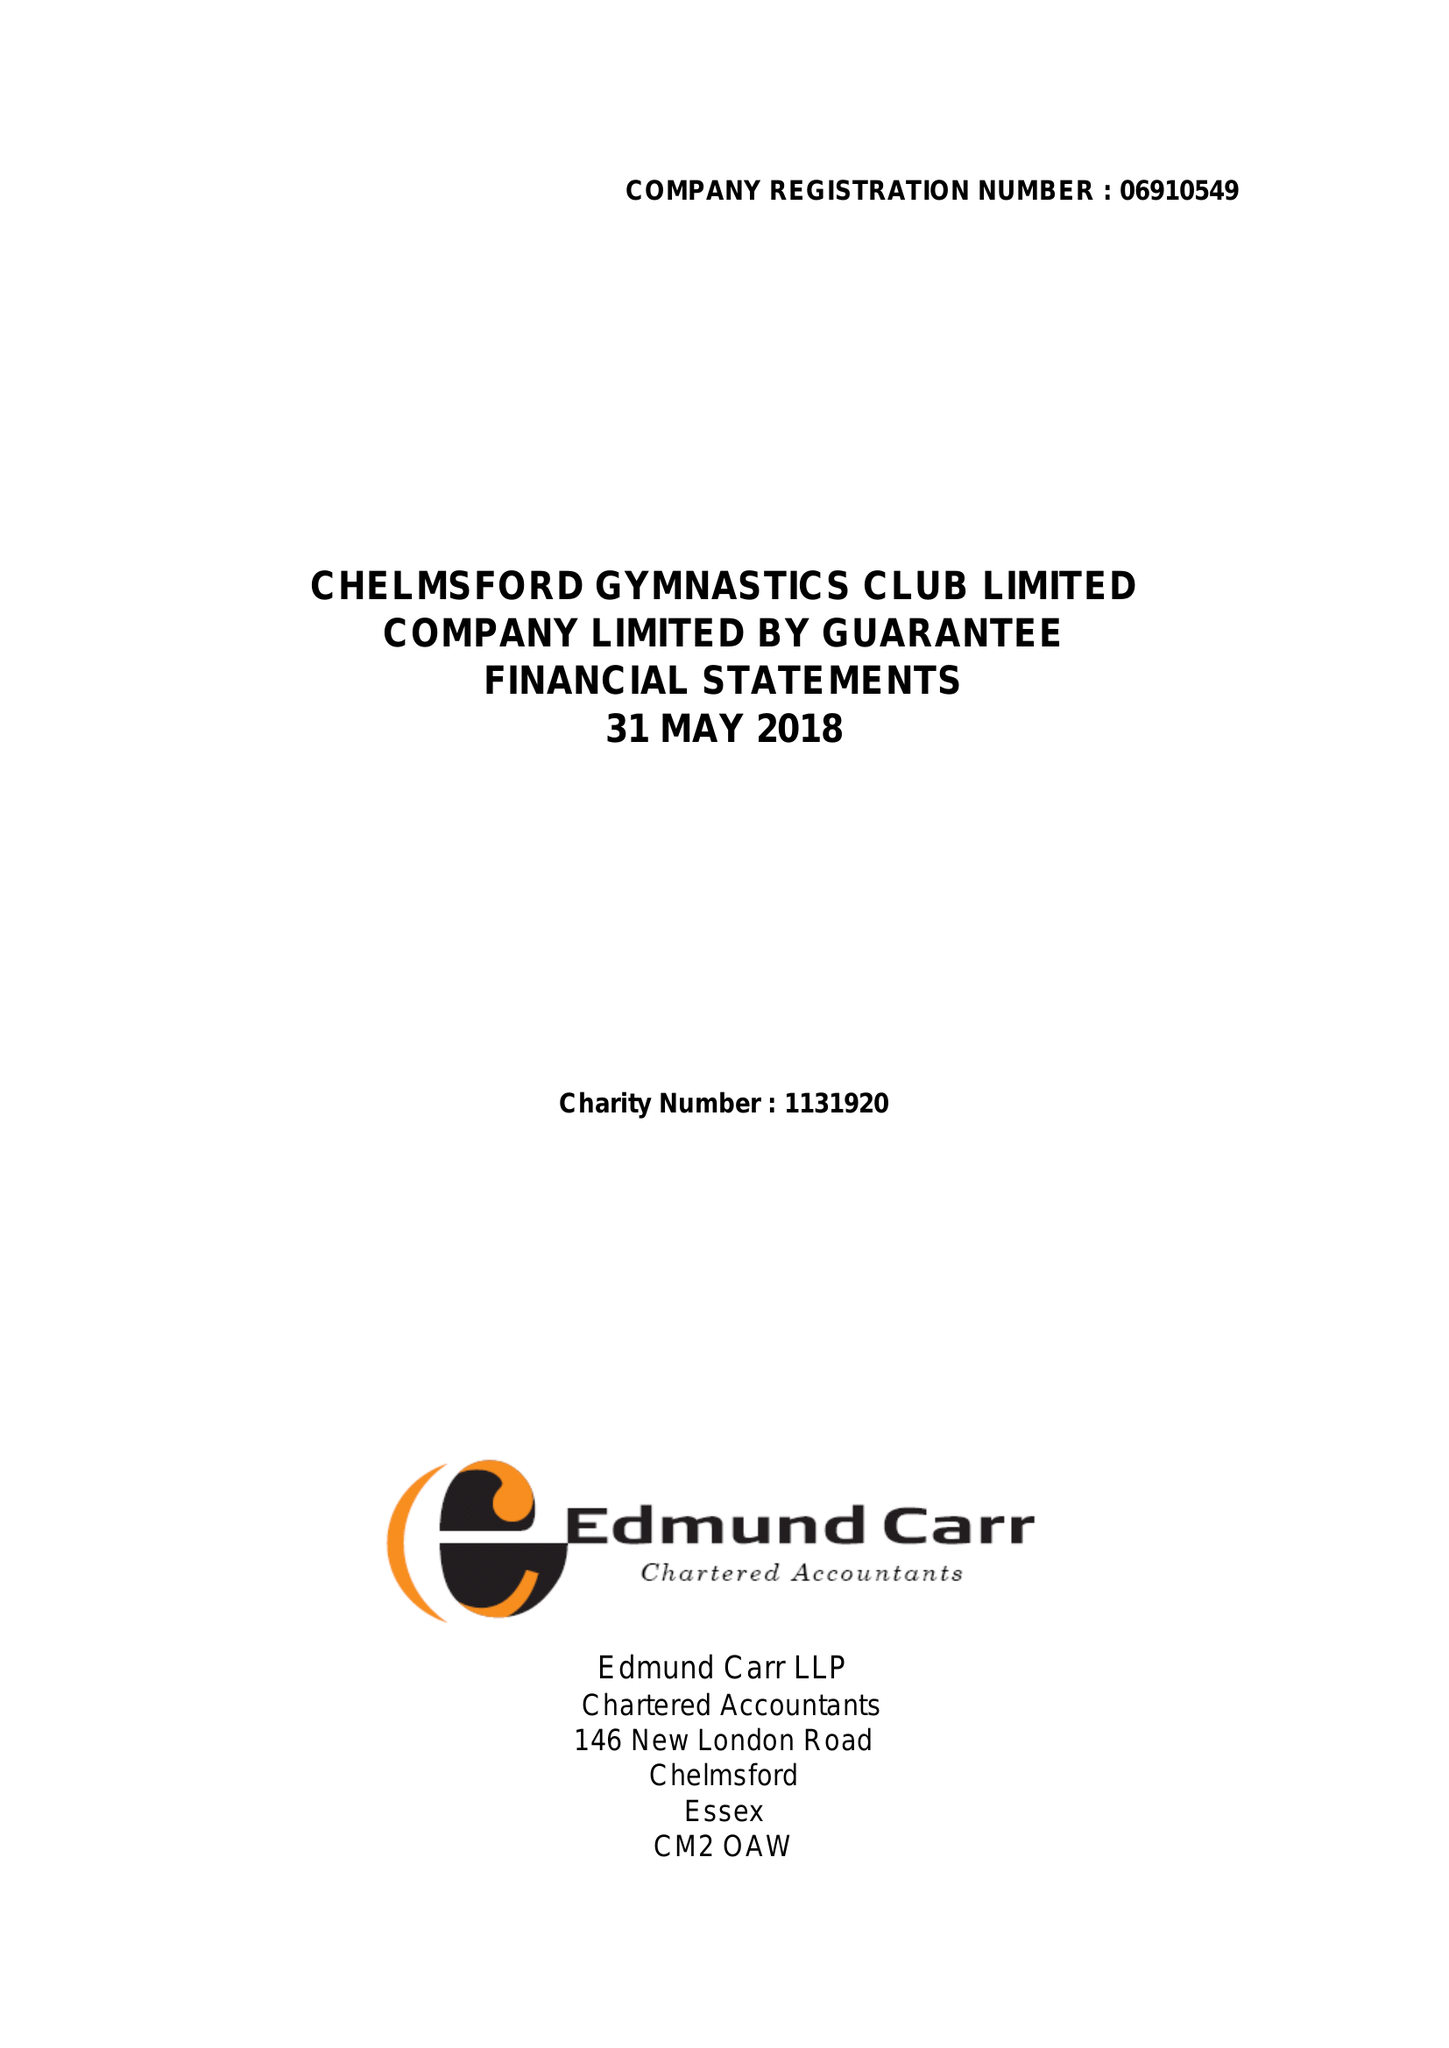What is the value for the charity_number?
Answer the question using a single word or phrase. 1131920 